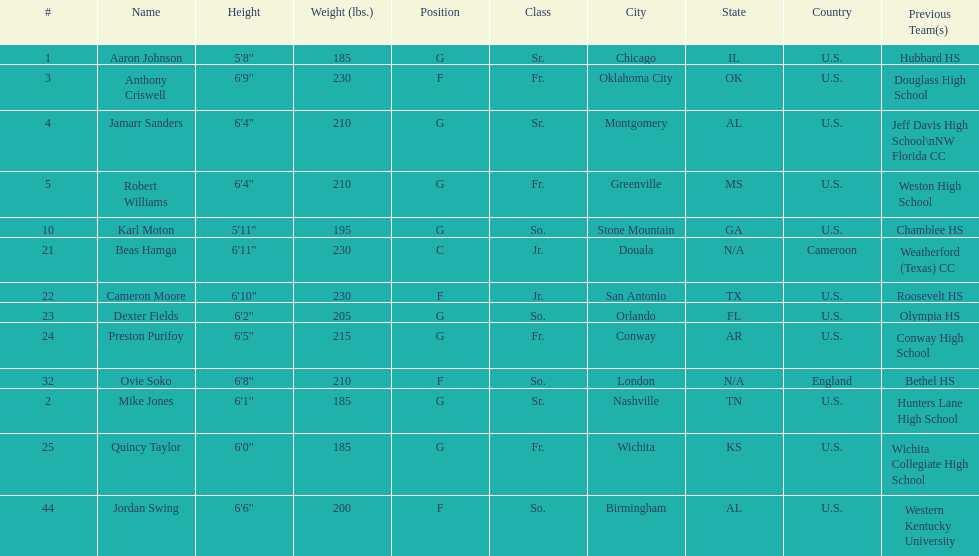What is the average weight of jamarr sanders and robert williams? 210. 